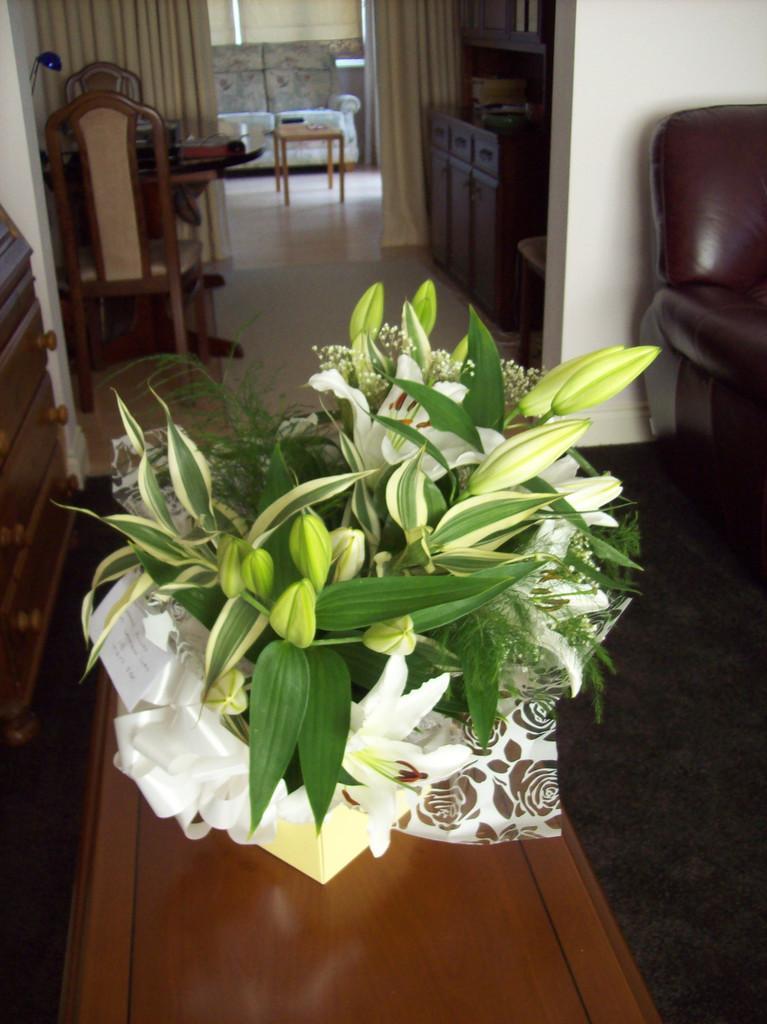Could you give a brief overview of what you see in this image? This is the picture taken in a home, this is a table on the table there is a flower pot. Behind the flower pot there are chairs and tables and a wall. 